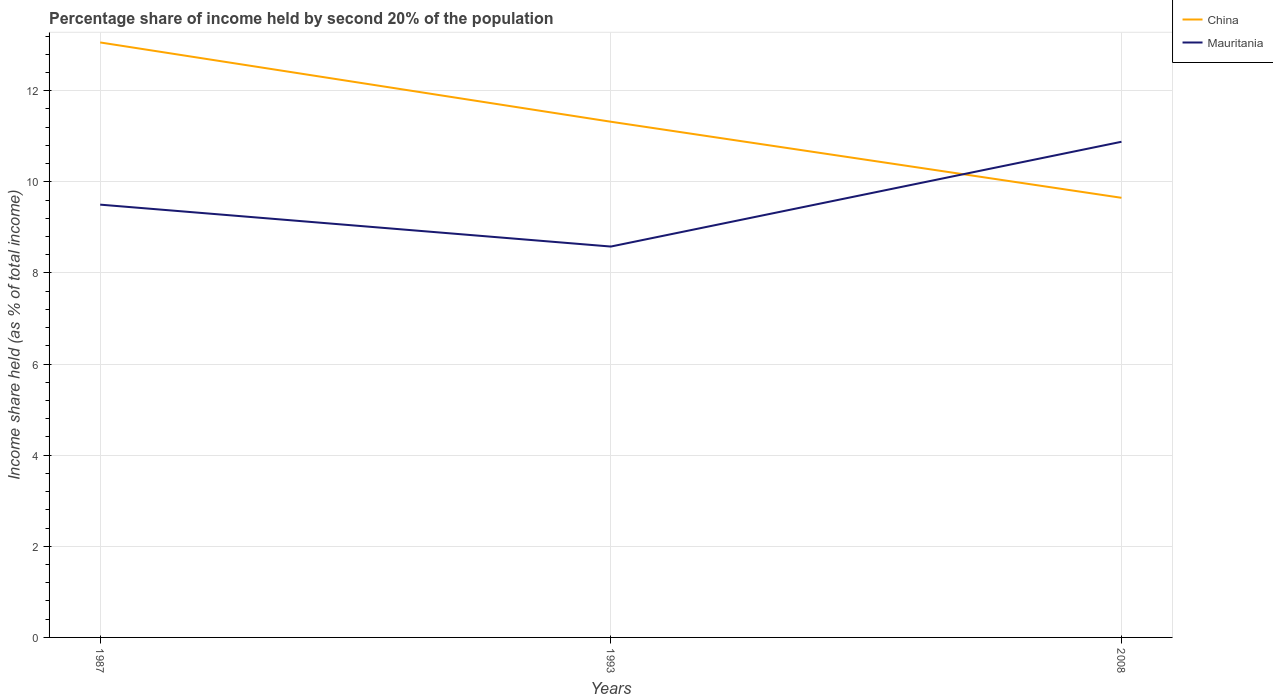Does the line corresponding to China intersect with the line corresponding to Mauritania?
Offer a very short reply. Yes. Across all years, what is the maximum share of income held by second 20% of the population in Mauritania?
Offer a terse response. 8.58. In which year was the share of income held by second 20% of the population in China maximum?
Provide a succinct answer. 2008. What is the total share of income held by second 20% of the population in Mauritania in the graph?
Make the answer very short. -1.38. What is the difference between the highest and the second highest share of income held by second 20% of the population in Mauritania?
Offer a very short reply. 2.3. Is the share of income held by second 20% of the population in Mauritania strictly greater than the share of income held by second 20% of the population in China over the years?
Provide a short and direct response. No. What is the difference between two consecutive major ticks on the Y-axis?
Provide a succinct answer. 2. Are the values on the major ticks of Y-axis written in scientific E-notation?
Your answer should be very brief. No. Does the graph contain grids?
Provide a short and direct response. Yes. Where does the legend appear in the graph?
Provide a succinct answer. Top right. What is the title of the graph?
Keep it short and to the point. Percentage share of income held by second 20% of the population. Does "Middle East & North Africa (all income levels)" appear as one of the legend labels in the graph?
Make the answer very short. No. What is the label or title of the X-axis?
Ensure brevity in your answer.  Years. What is the label or title of the Y-axis?
Your answer should be very brief. Income share held (as % of total income). What is the Income share held (as % of total income) of China in 1987?
Ensure brevity in your answer.  13.06. What is the Income share held (as % of total income) in Mauritania in 1987?
Make the answer very short. 9.5. What is the Income share held (as % of total income) in China in 1993?
Ensure brevity in your answer.  11.32. What is the Income share held (as % of total income) in Mauritania in 1993?
Your answer should be compact. 8.58. What is the Income share held (as % of total income) of China in 2008?
Provide a succinct answer. 9.65. What is the Income share held (as % of total income) in Mauritania in 2008?
Ensure brevity in your answer.  10.88. Across all years, what is the maximum Income share held (as % of total income) of China?
Keep it short and to the point. 13.06. Across all years, what is the maximum Income share held (as % of total income) in Mauritania?
Offer a very short reply. 10.88. Across all years, what is the minimum Income share held (as % of total income) of China?
Your answer should be compact. 9.65. Across all years, what is the minimum Income share held (as % of total income) of Mauritania?
Your answer should be very brief. 8.58. What is the total Income share held (as % of total income) in China in the graph?
Offer a terse response. 34.03. What is the total Income share held (as % of total income) of Mauritania in the graph?
Ensure brevity in your answer.  28.96. What is the difference between the Income share held (as % of total income) in China in 1987 and that in 1993?
Make the answer very short. 1.74. What is the difference between the Income share held (as % of total income) of China in 1987 and that in 2008?
Provide a succinct answer. 3.41. What is the difference between the Income share held (as % of total income) of Mauritania in 1987 and that in 2008?
Provide a succinct answer. -1.38. What is the difference between the Income share held (as % of total income) of China in 1993 and that in 2008?
Keep it short and to the point. 1.67. What is the difference between the Income share held (as % of total income) in China in 1987 and the Income share held (as % of total income) in Mauritania in 1993?
Provide a succinct answer. 4.48. What is the difference between the Income share held (as % of total income) of China in 1987 and the Income share held (as % of total income) of Mauritania in 2008?
Provide a succinct answer. 2.18. What is the difference between the Income share held (as % of total income) of China in 1993 and the Income share held (as % of total income) of Mauritania in 2008?
Make the answer very short. 0.44. What is the average Income share held (as % of total income) in China per year?
Provide a succinct answer. 11.34. What is the average Income share held (as % of total income) in Mauritania per year?
Make the answer very short. 9.65. In the year 1987, what is the difference between the Income share held (as % of total income) of China and Income share held (as % of total income) of Mauritania?
Your answer should be very brief. 3.56. In the year 1993, what is the difference between the Income share held (as % of total income) in China and Income share held (as % of total income) in Mauritania?
Your answer should be compact. 2.74. In the year 2008, what is the difference between the Income share held (as % of total income) in China and Income share held (as % of total income) in Mauritania?
Your answer should be compact. -1.23. What is the ratio of the Income share held (as % of total income) of China in 1987 to that in 1993?
Provide a short and direct response. 1.15. What is the ratio of the Income share held (as % of total income) in Mauritania in 1987 to that in 1993?
Offer a very short reply. 1.11. What is the ratio of the Income share held (as % of total income) in China in 1987 to that in 2008?
Your answer should be very brief. 1.35. What is the ratio of the Income share held (as % of total income) in Mauritania in 1987 to that in 2008?
Offer a terse response. 0.87. What is the ratio of the Income share held (as % of total income) of China in 1993 to that in 2008?
Give a very brief answer. 1.17. What is the ratio of the Income share held (as % of total income) of Mauritania in 1993 to that in 2008?
Offer a terse response. 0.79. What is the difference between the highest and the second highest Income share held (as % of total income) of China?
Give a very brief answer. 1.74. What is the difference between the highest and the second highest Income share held (as % of total income) of Mauritania?
Keep it short and to the point. 1.38. What is the difference between the highest and the lowest Income share held (as % of total income) in China?
Provide a short and direct response. 3.41. 